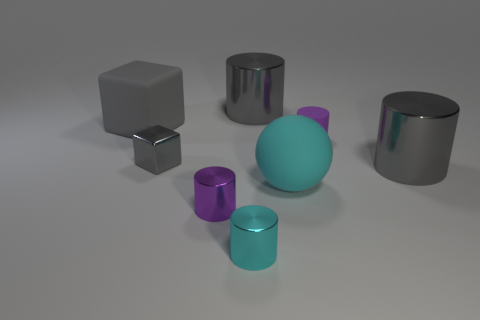Subtract all gray cylinders. How many were subtracted if there are1gray cylinders left? 1 Subtract all cyan cylinders. How many cylinders are left? 4 Subtract 1 cylinders. How many cylinders are left? 4 Add 2 small cyan metal cylinders. How many objects exist? 10 Subtract all gray cylinders. How many cylinders are left? 3 Subtract all balls. How many objects are left? 7 Subtract all gray cylinders. Subtract all gray cubes. How many cylinders are left? 3 Add 3 purple metal cubes. How many purple metal cubes exist? 3 Subtract 0 yellow blocks. How many objects are left? 8 Subtract all cyan spheres. How many gray cylinders are left? 2 